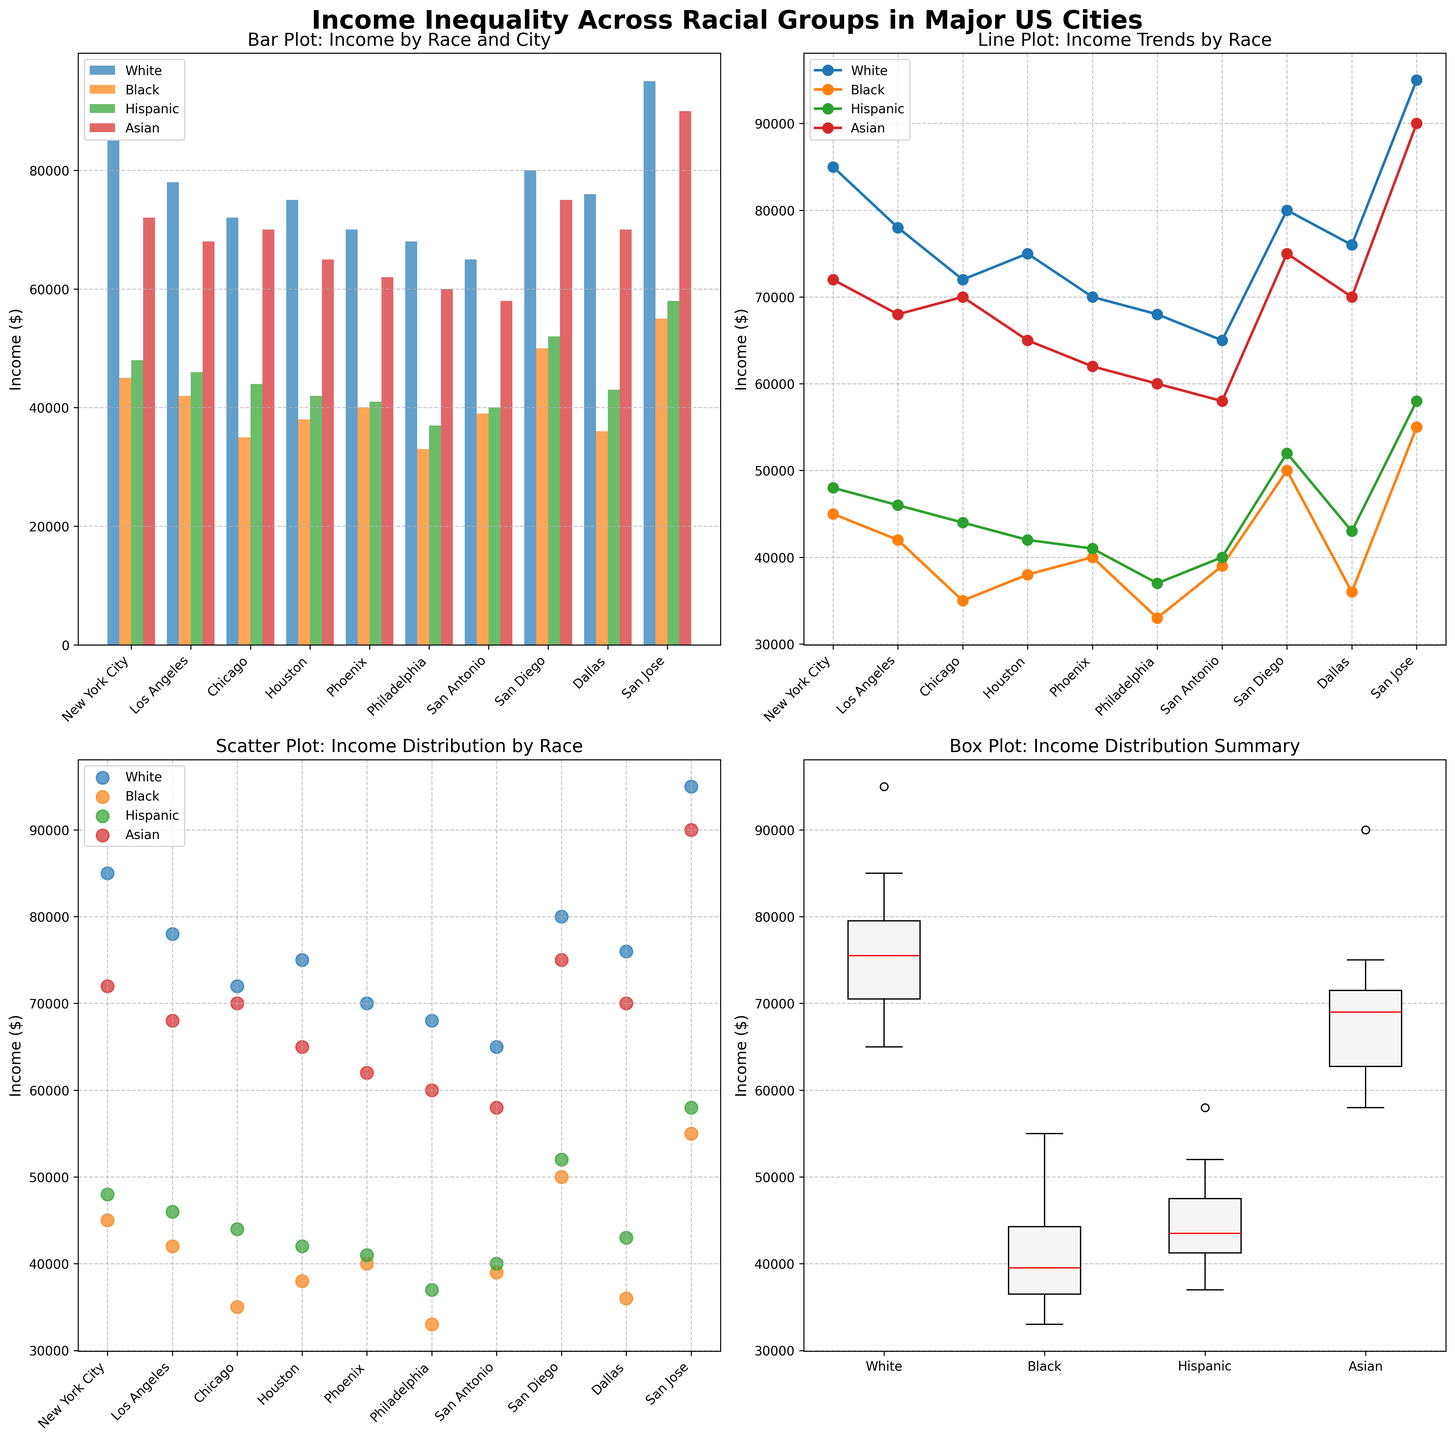what is the highest income for Black individuals and in which city? To find the highest income for Black individuals, look at the data series for the Black group in any of the subplots, and identify the highest point. The highest income for Black individuals is in San Jose.
Answer: 55000 in San Jose how does the income of Hispanic individuals in Phoenix compare to those in Chicago? In the bar plot, find the bars representing Hispanic income for Phoenix and Chicago. In Phoenix, the income is 41000, and in Chicago, it is 44000. Therefore, Hispanic individuals in Phoenix earn less compared to those in Chicago by 3000.
Answer: Lower by 3000 what is the median income for White individuals across all cities shown in the box plot? In the box plot for the White group, locate the red line inside the box, representing the median. Here, the median income for White individuals across all cities is 75000.
Answer: 75000 which racial group shows the most significant income disparity in Houston compared to New York City? Compare the income values of each racial group between Houston and New York City. The biggest disparity is observed in the Black group, with a difference of 45000 (45000 in New York City vs. 38000 in Houston).
Answer: Black group is the income trend for Asian individuals more consistent compared to Hispanic individuals based on the line plot? In the line plot, observe the curves for Asian and Hispanic groups. The curve for the Asian group has fewer fluctuations and appears smoother than for Hispanic individuals, indicating a more consistent trend.
Answer: Yes in which city do White individuals earn the least, and what is their income there? In the bar plot, locate the city with the smallest bar height for the White group. The lowest income for White individuals is in San Antonio, with an income of 65000.
Answer: San Antonio, 65000 what is the average income disparity between White and Black individuals across all cities? For each city, calculate the difference between White and Black incomes, sum up these differences, and divide by the number of cities (10). The average disparity is calculated as: ((85000-45000) + (78000-42000) + (72000-35000) + ... + (95000-55000)) / 10 = 34500.
Answer: 34500 how many cities have Hispanic incomes higher than 45000? Check each of the cities’ Hispanic income values across the subplots. Cities with Hispanic income higher than 45000 are New York City, Los Angeles, San Diego, San Jose. So, the total count is 4.
Answer: 4 which city shows the highest income for Asian individuals, and what is that income? In the bar or line plot, identify the highest point for the Asian group's income. The highest income for Asian individuals is in San Jose, at 90000.
Answer: San Jose, 90000 for which racial group is the income variance across cities the smallest? To determine the income variance, check the box plot and observe the width of each box. The smallest variance is seen in the Asian group's box, indicating the smallest income variance.
Answer: Asian group 